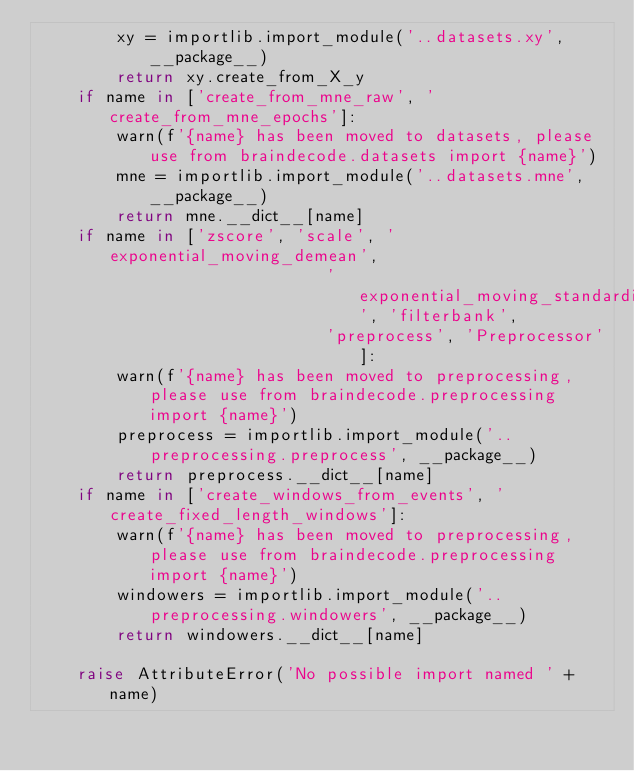<code> <loc_0><loc_0><loc_500><loc_500><_Python_>        xy = importlib.import_module('..datasets.xy', __package__)
        return xy.create_from_X_y
    if name in ['create_from_mne_raw', 'create_from_mne_epochs']:
        warn(f'{name} has been moved to datasets, please use from braindecode.datasets import {name}')
        mne = importlib.import_module('..datasets.mne', __package__)
        return mne.__dict__[name]
    if name in ['zscore', 'scale', 'exponential_moving_demean',
                             'exponential_moving_standardize', 'filterbank',
                             'preprocess', 'Preprocessor']:
        warn(f'{name} has been moved to preprocessing, please use from braindecode.preprocessing import {name}')
        preprocess = importlib.import_module('..preprocessing.preprocess', __package__)
        return preprocess.__dict__[name]
    if name in ['create_windows_from_events', 'create_fixed_length_windows']:
        warn(f'{name} has been moved to preprocessing, please use from braindecode.preprocessing import {name}')
        windowers = importlib.import_module('..preprocessing.windowers', __package__)
        return windowers.__dict__[name]

    raise AttributeError('No possible import named ' + name)
</code> 